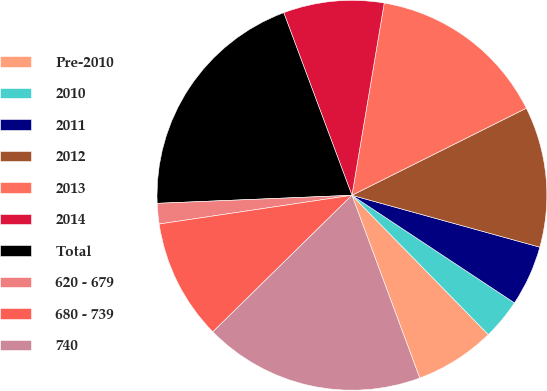Convert chart to OTSL. <chart><loc_0><loc_0><loc_500><loc_500><pie_chart><fcel>Pre-2010<fcel>2010<fcel>2011<fcel>2012<fcel>2013<fcel>2014<fcel>Total<fcel>620 - 679<fcel>680 - 739<fcel>740<nl><fcel>6.68%<fcel>3.36%<fcel>5.02%<fcel>11.66%<fcel>14.98%<fcel>8.34%<fcel>19.97%<fcel>1.7%<fcel>10.0%<fcel>18.3%<nl></chart> 